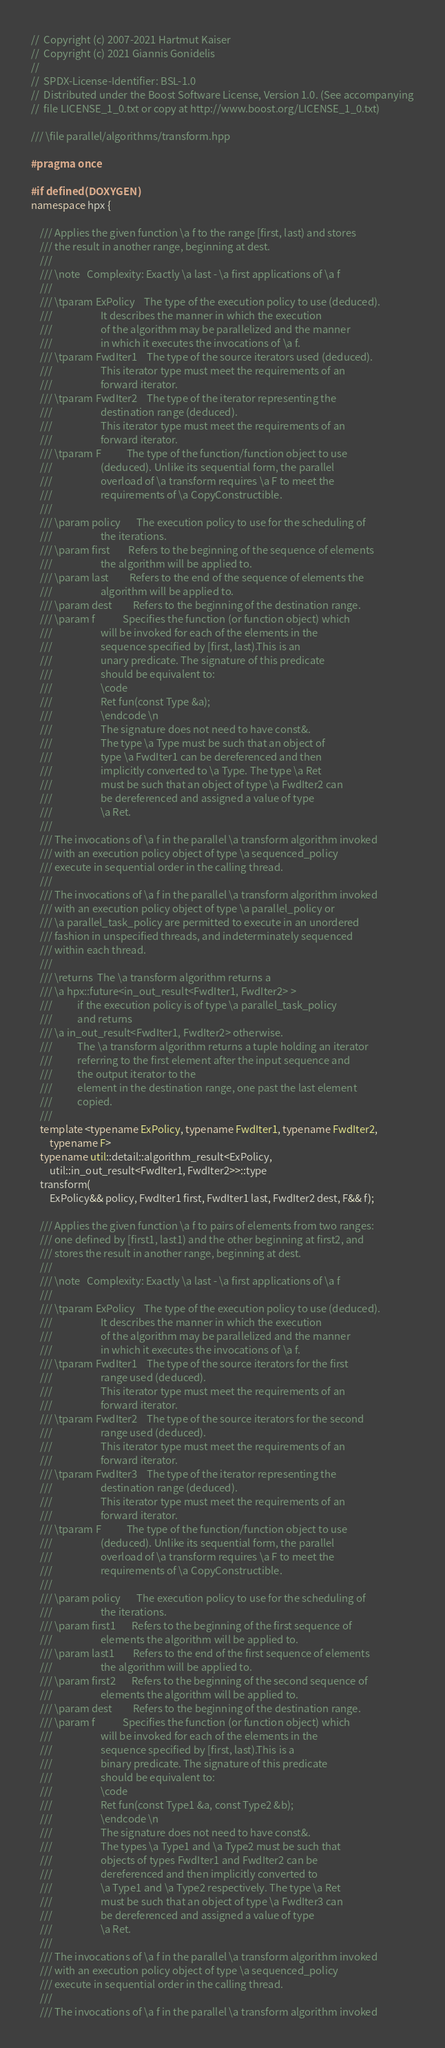<code> <loc_0><loc_0><loc_500><loc_500><_C++_>//  Copyright (c) 2007-2021 Hartmut Kaiser
//  Copyright (c) 2021 Giannis Gonidelis
//
//  SPDX-License-Identifier: BSL-1.0
//  Distributed under the Boost Software License, Version 1.0. (See accompanying
//  file LICENSE_1_0.txt or copy at http://www.boost.org/LICENSE_1_0.txt)

/// \file parallel/algorithms/transform.hpp

#pragma once

#if defined(DOXYGEN)
namespace hpx {

    /// Applies the given function \a f to the range [first, last) and stores
    /// the result in another range, beginning at dest.
    ///
    /// \note   Complexity: Exactly \a last - \a first applications of \a f
    ///
    /// \tparam ExPolicy    The type of the execution policy to use (deduced).
    ///                     It describes the manner in which the execution
    ///                     of the algorithm may be parallelized and the manner
    ///                     in which it executes the invocations of \a f.
    /// \tparam FwdIter1    The type of the source iterators used (deduced).
    ///                     This iterator type must meet the requirements of an
    ///                     forward iterator.
    /// \tparam FwdIter2    The type of the iterator representing the
    ///                     destination range (deduced).
    ///                     This iterator type must meet the requirements of an
    ///                     forward iterator.
    /// \tparam F           The type of the function/function object to use
    ///                     (deduced). Unlike its sequential form, the parallel
    ///                     overload of \a transform requires \a F to meet the
    ///                     requirements of \a CopyConstructible.
    ///
    /// \param policy       The execution policy to use for the scheduling of
    ///                     the iterations.
    /// \param first        Refers to the beginning of the sequence of elements
    ///                     the algorithm will be applied to.
    /// \param last         Refers to the end of the sequence of elements the
    ///                     algorithm will be applied to.
    /// \param dest         Refers to the beginning of the destination range.
    /// \param f            Specifies the function (or function object) which
    ///                     will be invoked for each of the elements in the
    ///                     sequence specified by [first, last).This is an
    ///                     unary predicate. The signature of this predicate
    ///                     should be equivalent to:
    ///                     \code
    ///                     Ret fun(const Type &a);
    ///                     \endcode \n
    ///                     The signature does not need to have const&.
    ///                     The type \a Type must be such that an object of
    ///                     type \a FwdIter1 can be dereferenced and then
    ///                     implicitly converted to \a Type. The type \a Ret
    ///                     must be such that an object of type \a FwdIter2 can
    ///                     be dereferenced and assigned a value of type
    ///                     \a Ret.
    ///
    /// The invocations of \a f in the parallel \a transform algorithm invoked
    /// with an execution policy object of type \a sequenced_policy
    /// execute in sequential order in the calling thread.
    ///
    /// The invocations of \a f in the parallel \a transform algorithm invoked
    /// with an execution policy object of type \a parallel_policy or
    /// \a parallel_task_policy are permitted to execute in an unordered
    /// fashion in unspecified threads, and indeterminately sequenced
    /// within each thread.
    ///
    /// \returns  The \a transform algorithm returns a
    /// \a hpx::future<in_out_result<FwdIter1, FwdIter2> >
    ///           if the execution policy is of type \a parallel_task_policy
    ///           and returns
    /// \a in_out_result<FwdIter1, FwdIter2> otherwise.
    ///           The \a transform algorithm returns a tuple holding an iterator
    ///           referring to the first element after the input sequence and
    ///           the output iterator to the
    ///           element in the destination range, one past the last element
    ///           copied.
    ///
    template <typename ExPolicy, typename FwdIter1, typename FwdIter2,
        typename F>
    typename util::detail::algorithm_result<ExPolicy,
        util::in_out_result<FwdIter1, FwdIter2>>::type
    transform(
        ExPolicy&& policy, FwdIter1 first, FwdIter1 last, FwdIter2 dest, F&& f);

    /// Applies the given function \a f to pairs of elements from two ranges:
    /// one defined by [first1, last1) and the other beginning at first2, and
    /// stores the result in another range, beginning at dest.
    ///
    /// \note   Complexity: Exactly \a last - \a first applications of \a f
    ///
    /// \tparam ExPolicy    The type of the execution policy to use (deduced).
    ///                     It describes the manner in which the execution
    ///                     of the algorithm may be parallelized and the manner
    ///                     in which it executes the invocations of \a f.
    /// \tparam FwdIter1    The type of the source iterators for the first
    ///                     range used (deduced).
    ///                     This iterator type must meet the requirements of an
    ///                     forward iterator.
    /// \tparam FwdIter2    The type of the source iterators for the second
    ///                     range used (deduced).
    ///                     This iterator type must meet the requirements of an
    ///                     forward iterator.
    /// \tparam FwdIter3    The type of the iterator representing the
    ///                     destination range (deduced).
    ///                     This iterator type must meet the requirements of an
    ///                     forward iterator.
    /// \tparam F           The type of the function/function object to use
    ///                     (deduced). Unlike its sequential form, the parallel
    ///                     overload of \a transform requires \a F to meet the
    ///                     requirements of \a CopyConstructible.
    ///
    /// \param policy       The execution policy to use for the scheduling of
    ///                     the iterations.
    /// \param first1       Refers to the beginning of the first sequence of
    ///                     elements the algorithm will be applied to.
    /// \param last1        Refers to the end of the first sequence of elements
    ///                     the algorithm will be applied to.
    /// \param first2       Refers to the beginning of the second sequence of
    ///                     elements the algorithm will be applied to.
    /// \param dest         Refers to the beginning of the destination range.
    /// \param f            Specifies the function (or function object) which
    ///                     will be invoked for each of the elements in the
    ///                     sequence specified by [first, last).This is a
    ///                     binary predicate. The signature of this predicate
    ///                     should be equivalent to:
    ///                     \code
    ///                     Ret fun(const Type1 &a, const Type2 &b);
    ///                     \endcode \n
    ///                     The signature does not need to have const&.
    ///                     The types \a Type1 and \a Type2 must be such that
    ///                     objects of types FwdIter1 and FwdIter2 can be
    ///                     dereferenced and then implicitly converted to
    ///                     \a Type1 and \a Type2 respectively. The type \a Ret
    ///                     must be such that an object of type \a FwdIter3 can
    ///                     be dereferenced and assigned a value of type
    ///                     \a Ret.
    ///
    /// The invocations of \a f in the parallel \a transform algorithm invoked
    /// with an execution policy object of type \a sequenced_policy
    /// execute in sequential order in the calling thread.
    ///
    /// The invocations of \a f in the parallel \a transform algorithm invoked</code> 